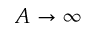<formula> <loc_0><loc_0><loc_500><loc_500>A \rightarrow \infty</formula> 